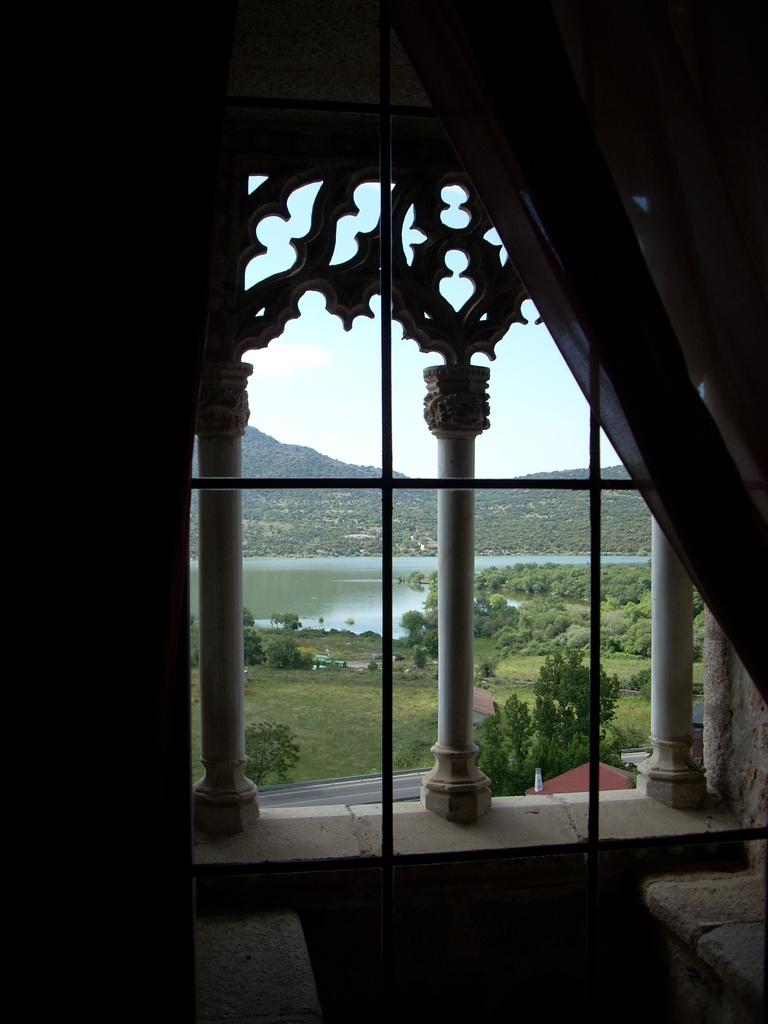What type of window treatment is present in the image? There are curtains in the image. What natural element is visible in the image? Water and trees are visible in the image. What is visible at the top of the image? The sky is visible at the top of the image. What is the income of the maid in the image? There is no maid present in the image, so it is not possible to determine their income. Can you describe the kitty playing with the income in the image? There is no kitty or income present in the image. 